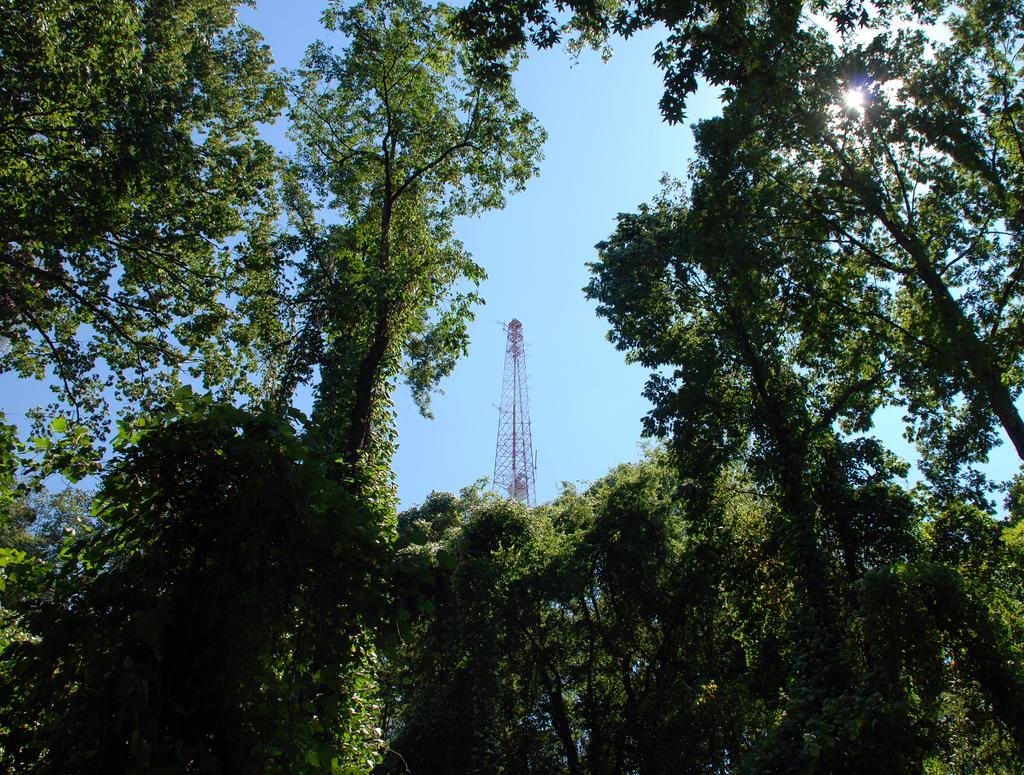What type of vegetation can be seen in the image? There are trees in the image. What structure is visible in the background? There is a tower visible in the background. What part of the natural environment is visible in the image? The sky is visible in the background of the image. Can the sun be seen in the image? Yes, the sun is observable in the sky. What kind of birthday celebration is taking place in the image? There is no indication of a birthday celebration in the image; it features trees, a tower, and the sky. Can you tell me which uncle is present in the image? There is no uncle present in the image. 